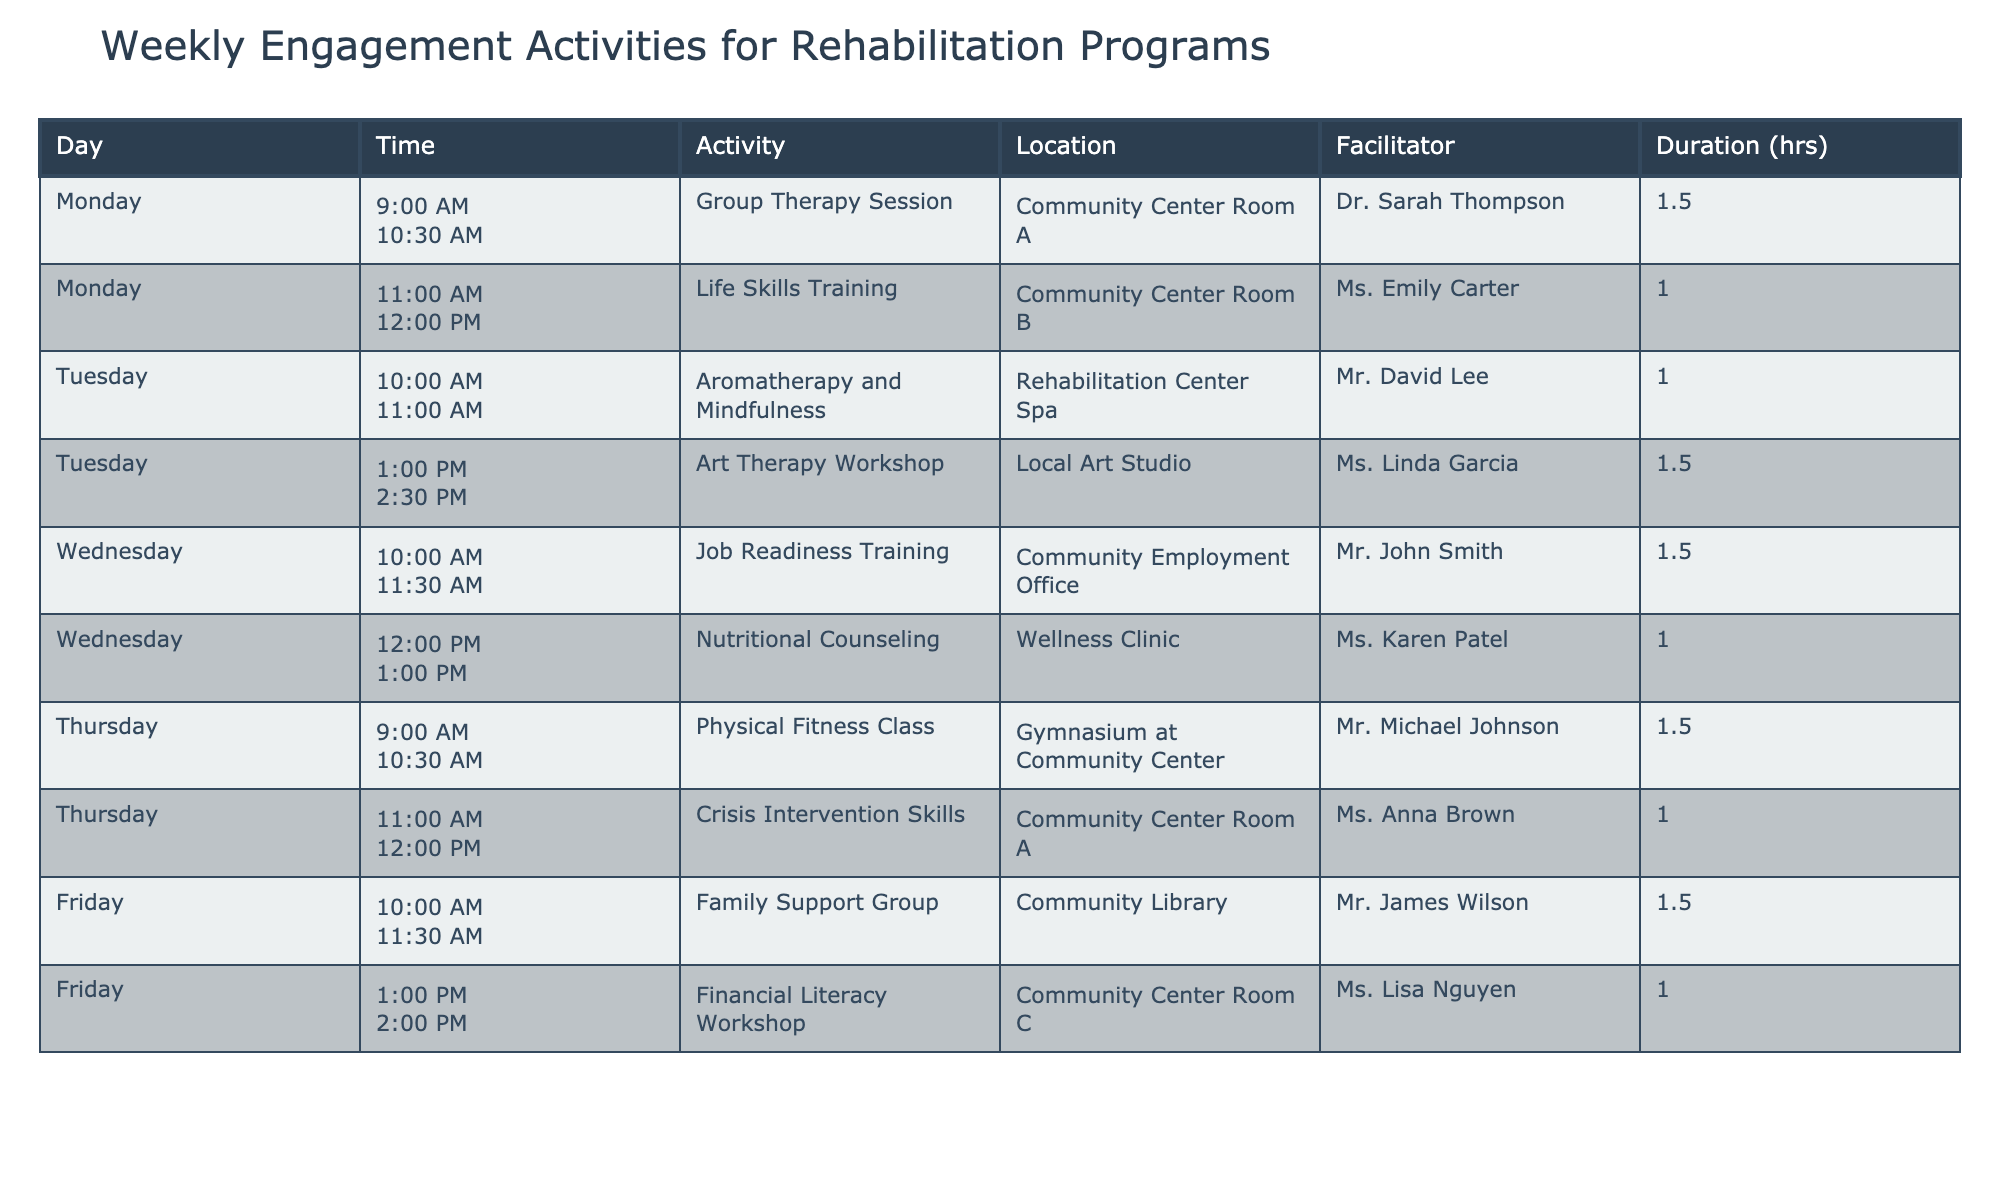What activity is scheduled for Tuesday at 10:00 AM? The table lists the activities along with their corresponding days and times. Looking at Tuesday's schedule, the activity at 10:00 AM is "Aromatherapy and Mindfulness."
Answer: Aromatherapy and Mindfulness How long is the Family Support Group session on Friday? From the table, the "Family Support Group" activity listed on Friday has a duration of 1.5 hours.
Answer: 1.5 hours Which facilitator is leading the Life Skills Training? By checking the column for facilitators, it is clear that "Life Skills Training" is led by Ms. Emily Carter.
Answer: Ms. Emily Carter Is there any activity scheduled on Wednesday after 12:00 PM? The table displays that the last activity on Wednesday is "Nutritional Counseling," which ends at 1:00 PM. Therefore, there are no further activities scheduled after that time on Wednesday, confirming the answer as no.
Answer: No What is the total duration of activities on Thursday? According to the table, on Thursday, there are two activities: "Physical Fitness Class" for 1.5 hours and "Crisis Intervention Skills" for 1 hour. Adding these durations together: 1.5 + 1 = 2.5 hours.
Answer: 2.5 hours On which day is the Art Therapy Workshop scheduled? The table indicates that the "Art Therapy Workshop" occurs on Tuesday.
Answer: Tuesday What is the average duration of activities taking place on Monday? The activities for Monday include "Group Therapy Session" for 1.5 hours and "Life Skills Training" for 1 hour. To calculate the average, add the durations: 1.5 + 1 = 2.5 hours, then divide by 2 (the number of activities): 2.5 / 2 = 1.25 hours.
Answer: 1.25 hours Does the Rehabilitation Center Spa have a session on Tuesday? The table confirms that the "Aromatherapy and Mindfulness" session is indeed scheduled at the Rehabilitation Center Spa on Tuesday.
Answer: Yes What is the difference in duration between the longest and shortest activities in the table? The longest activity is the "Group Therapy Session," which lasts 1.5 hours, while the shortest, "Life Skills Training," lasts 1 hour. Therefore, the duration difference is 1.5 - 1 = 0.5 hours.
Answer: 0.5 hours 